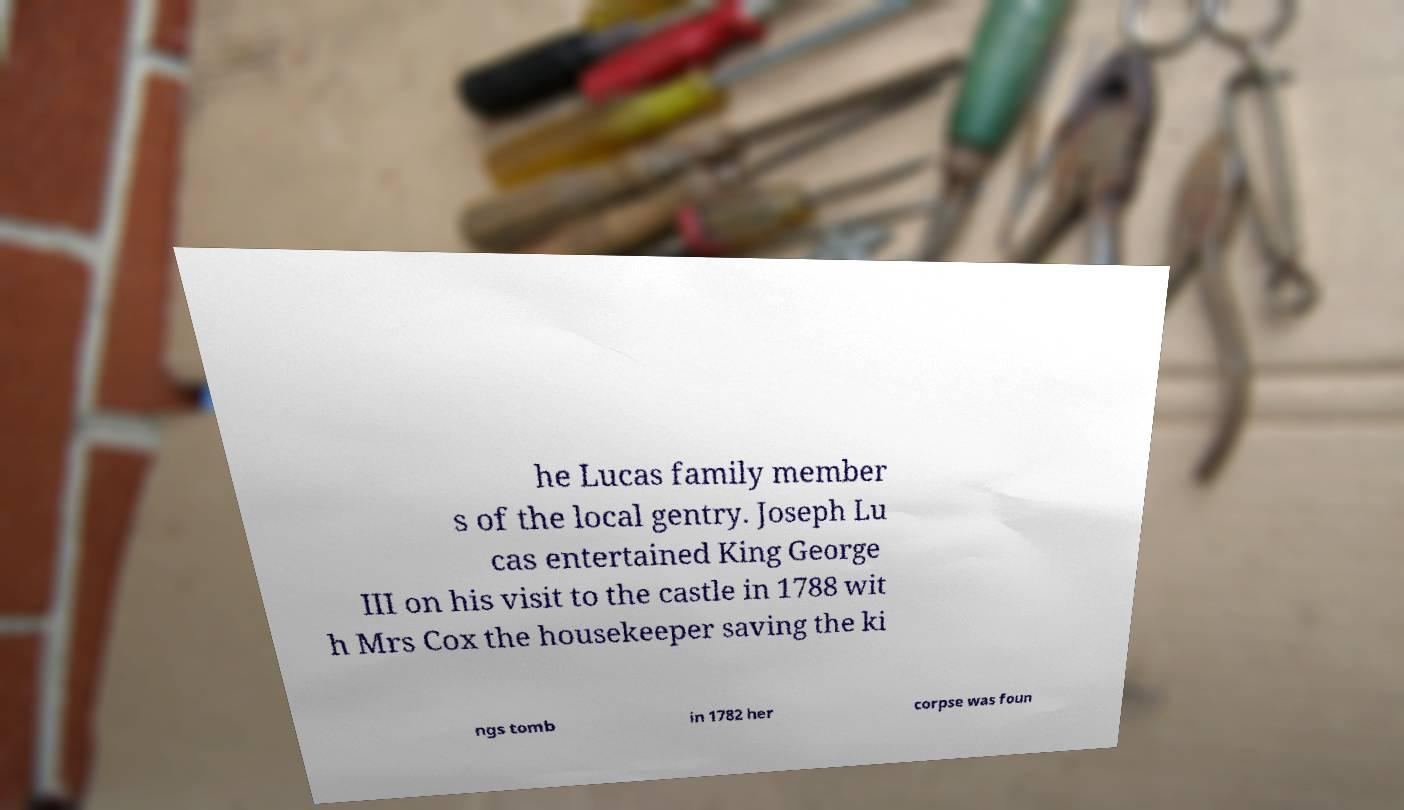For documentation purposes, I need the text within this image transcribed. Could you provide that? he Lucas family member s of the local gentry. Joseph Lu cas entertained King George III on his visit to the castle in 1788 wit h Mrs Cox the housekeeper saving the ki ngs tomb in 1782 her corpse was foun 